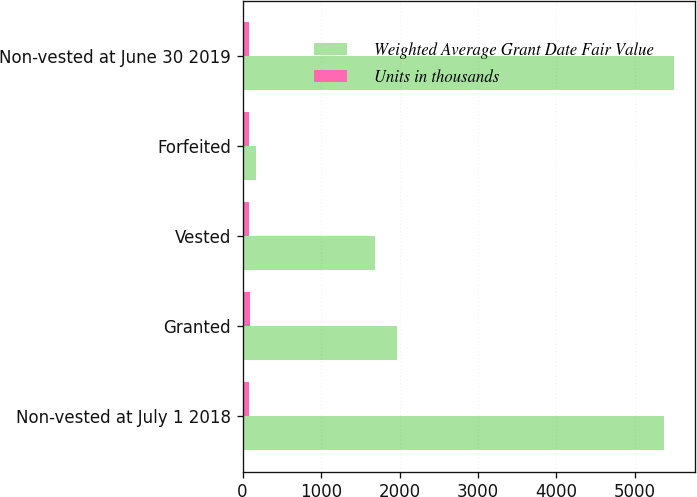Convert chart to OTSL. <chart><loc_0><loc_0><loc_500><loc_500><stacked_bar_chart><ecel><fcel>Non-vested at July 1 2018<fcel>Granted<fcel>Vested<fcel>Forfeited<fcel>Non-vested at June 30 2019<nl><fcel>Weighted Average Grant Date Fair Value<fcel>5376<fcel>1970<fcel>1685<fcel>168<fcel>5493<nl><fcel>Units in thousands<fcel>77.17<fcel>96.74<fcel>78.4<fcel>79.67<fcel>84<nl></chart> 